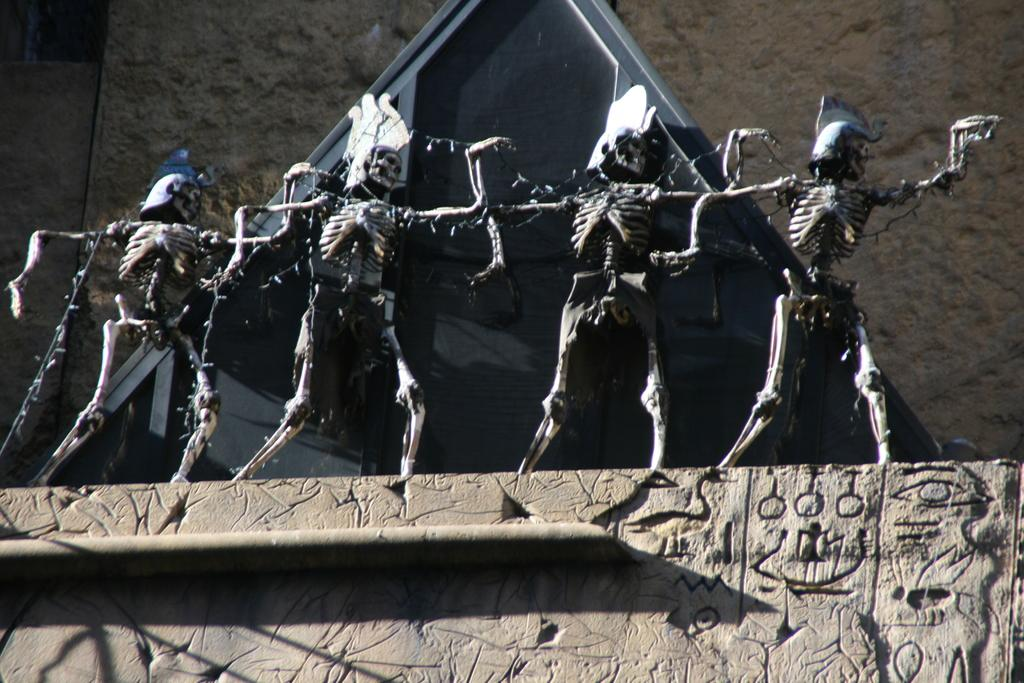What type of figures can be seen in the image? There are skeletons in the image. What is visible in the background of the image? There is a wall and an object in the background of the image. Can you describe the wall in the image? The wall has carvings at the top of the image. What type of representative prose can be seen on the rail in the image? There is no representative prose or rail present in the image. 